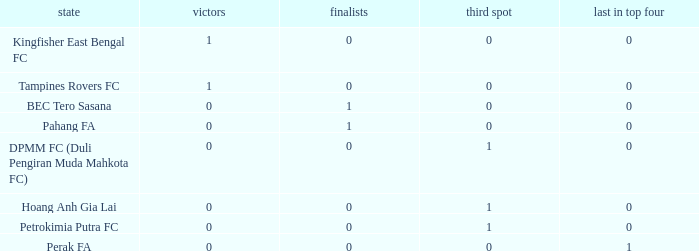Name the average 3rd place with winners of 0, 4th place of 0 and nation of pahang fa 0.0. 